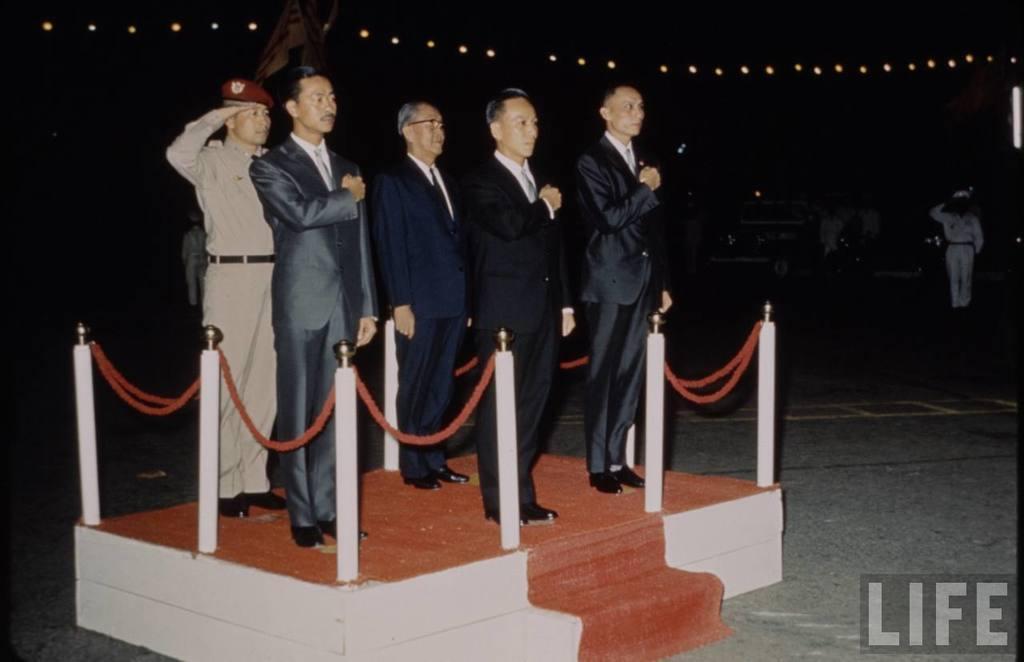Describe this image in one or two sentences. In this picture we can see five men are standing, four of them wore suits, on the right side we can see another person is standing, there are some lights at the top of the picture, we can see a dark background, at the right bottom there is some text. 